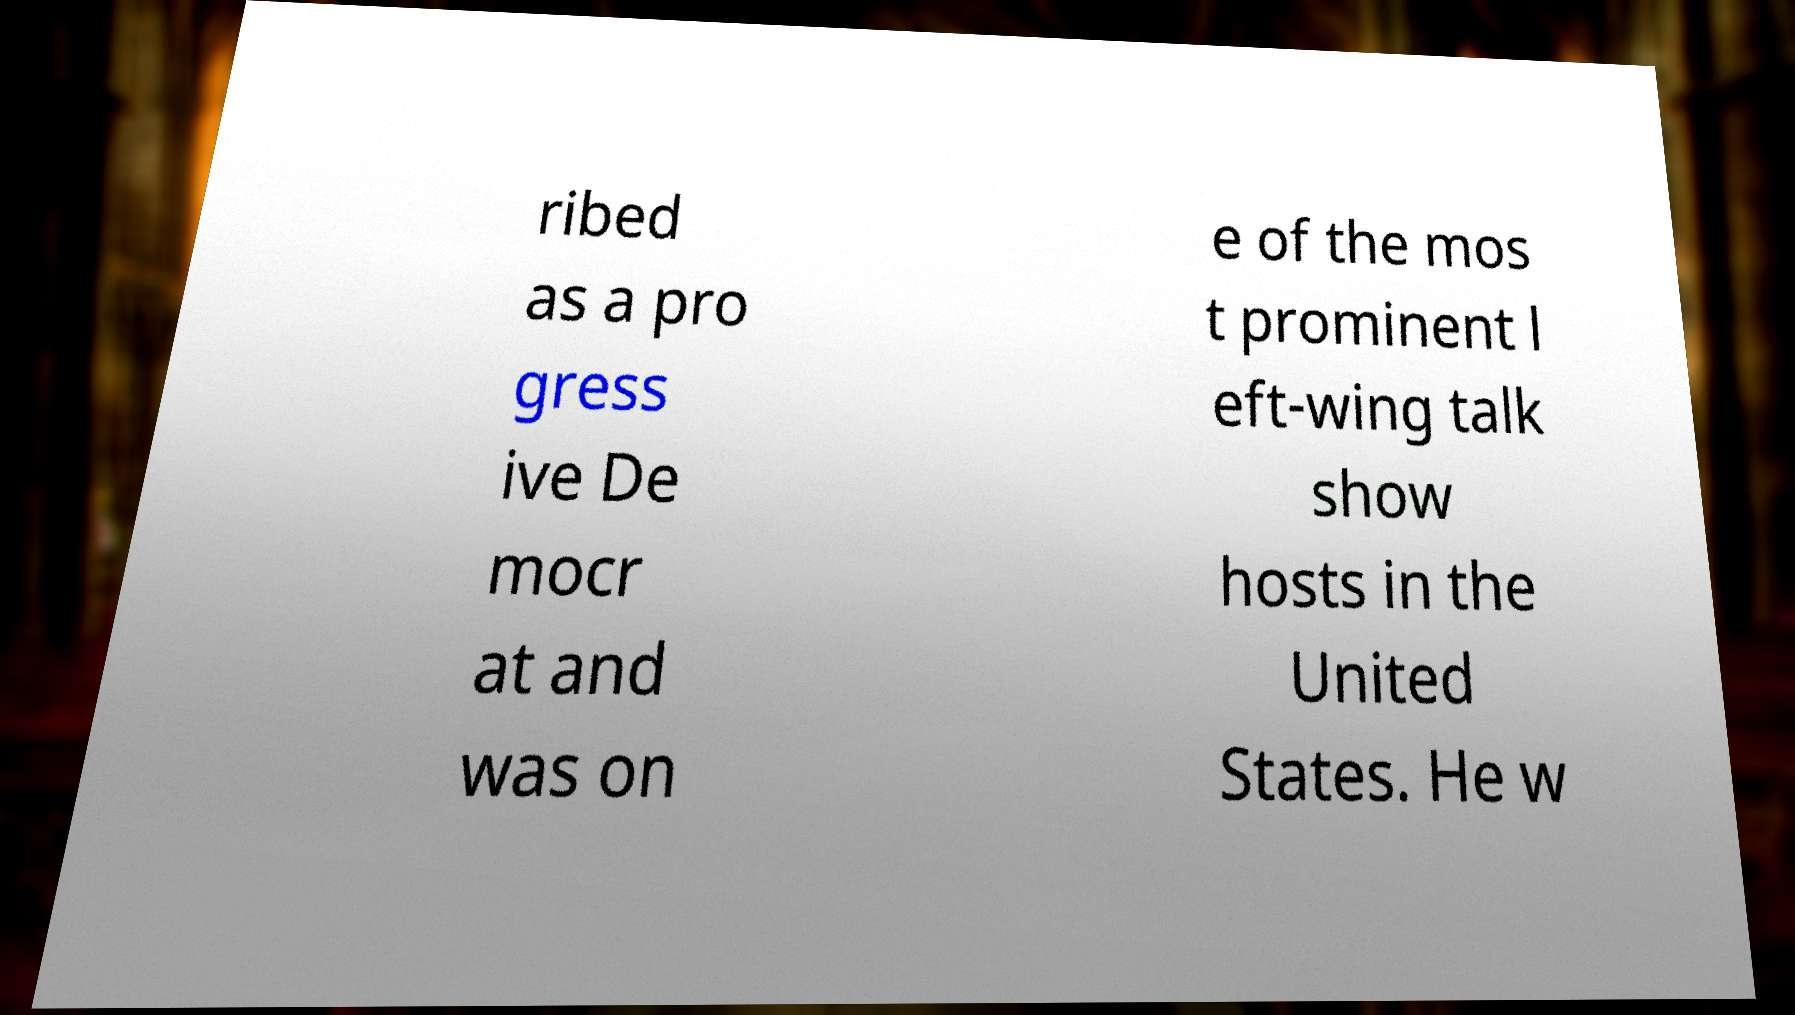Could you extract and type out the text from this image? ribed as a pro gress ive De mocr at and was on e of the mos t prominent l eft-wing talk show hosts in the United States. He w 